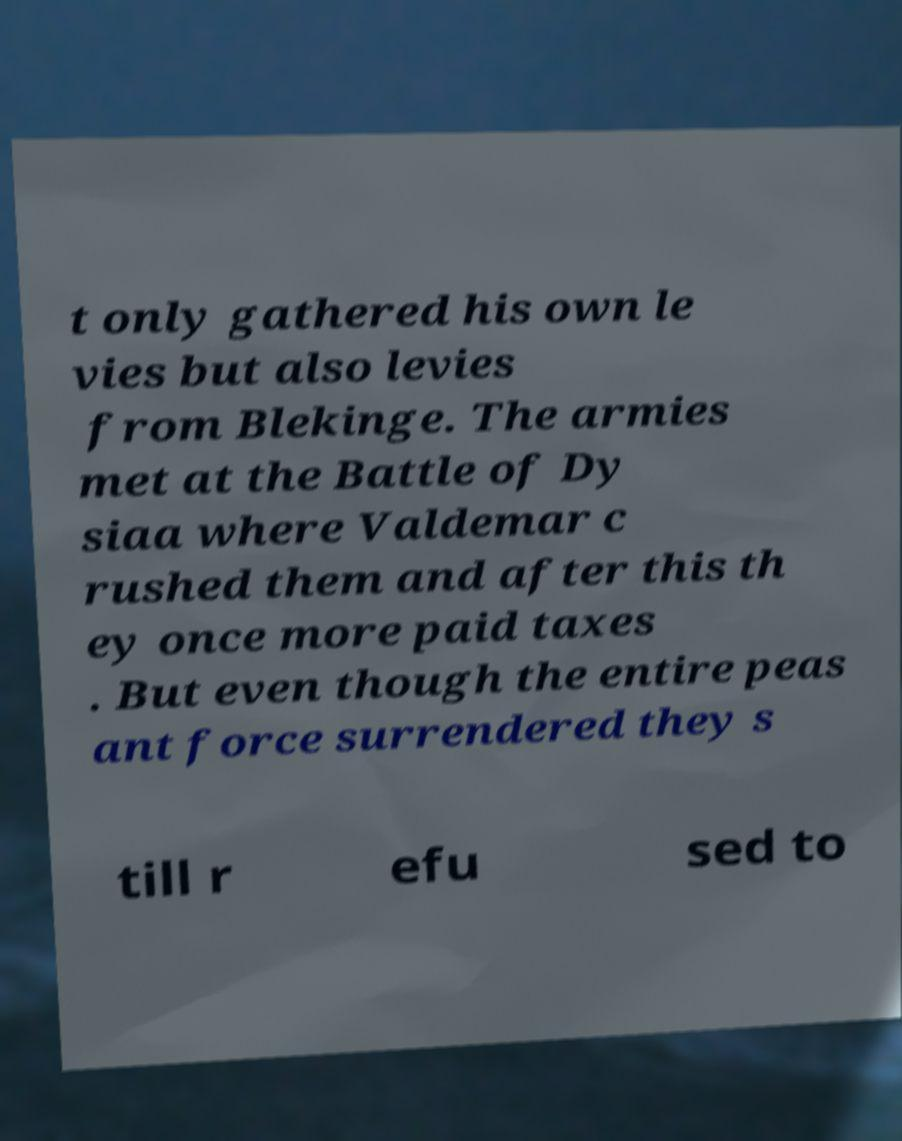Please identify and transcribe the text found in this image. t only gathered his own le vies but also levies from Blekinge. The armies met at the Battle of Dy siaa where Valdemar c rushed them and after this th ey once more paid taxes . But even though the entire peas ant force surrendered they s till r efu sed to 